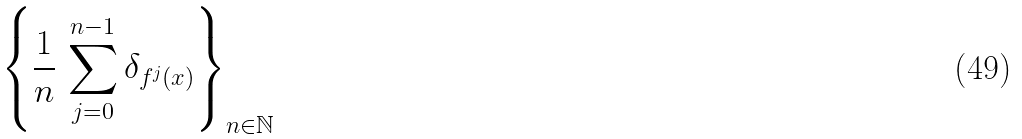<formula> <loc_0><loc_0><loc_500><loc_500>\left \{ \frac { 1 } { n } \, \sum _ { j = 0 } ^ { n - 1 } \delta _ { f ^ { j } ( x ) } \right \} _ { n \in \mathbb { N } }</formula> 